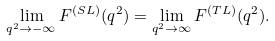<formula> <loc_0><loc_0><loc_500><loc_500>\lim _ { q ^ { 2 } \to - \infty } F ^ { ( S L ) } ( q ^ { 2 } ) = \lim _ { q ^ { 2 } \to \infty } F ^ { ( T L ) } ( q ^ { 2 } ) .</formula> 